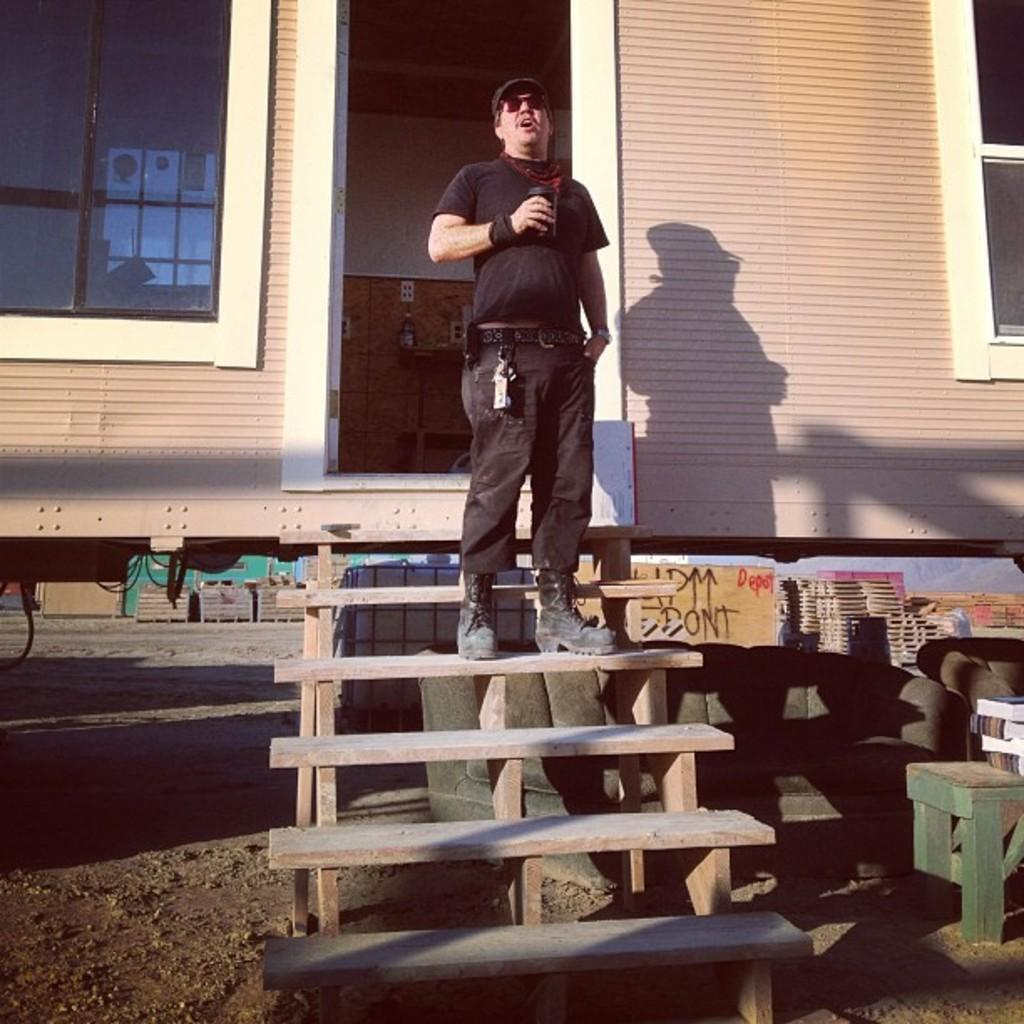What is the person in the image doing? The person is standing on a staircase in the image. What can be seen in the background of the image? There is a wall, windows, and a door in the background of the image. What type of vegetable is the person holding in the image? There is no vegetable present in the image; the person is simply standing on the staircase. 